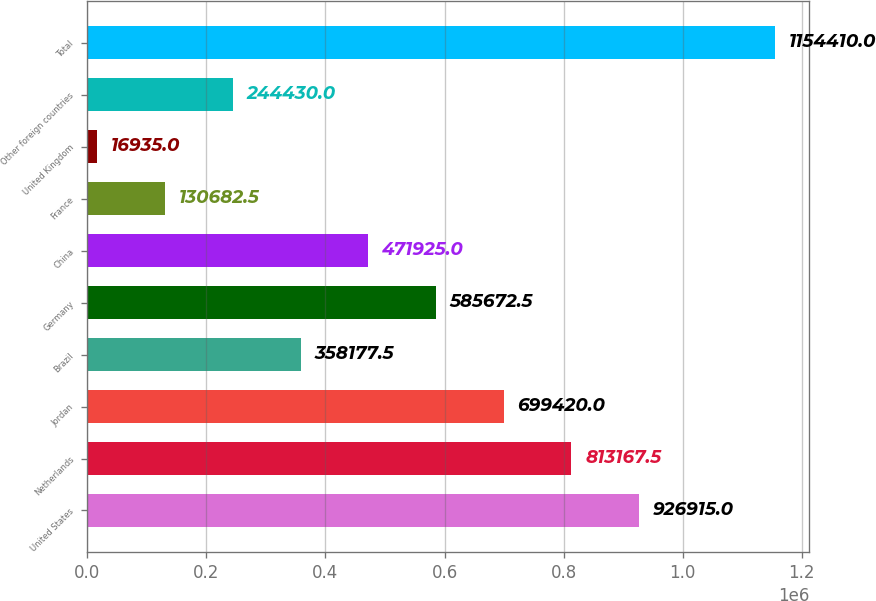Convert chart to OTSL. <chart><loc_0><loc_0><loc_500><loc_500><bar_chart><fcel>United States<fcel>Netherlands<fcel>Jordan<fcel>Brazil<fcel>Germany<fcel>China<fcel>France<fcel>United Kingdom<fcel>Other foreign countries<fcel>Total<nl><fcel>926915<fcel>813168<fcel>699420<fcel>358178<fcel>585672<fcel>471925<fcel>130682<fcel>16935<fcel>244430<fcel>1.15441e+06<nl></chart> 